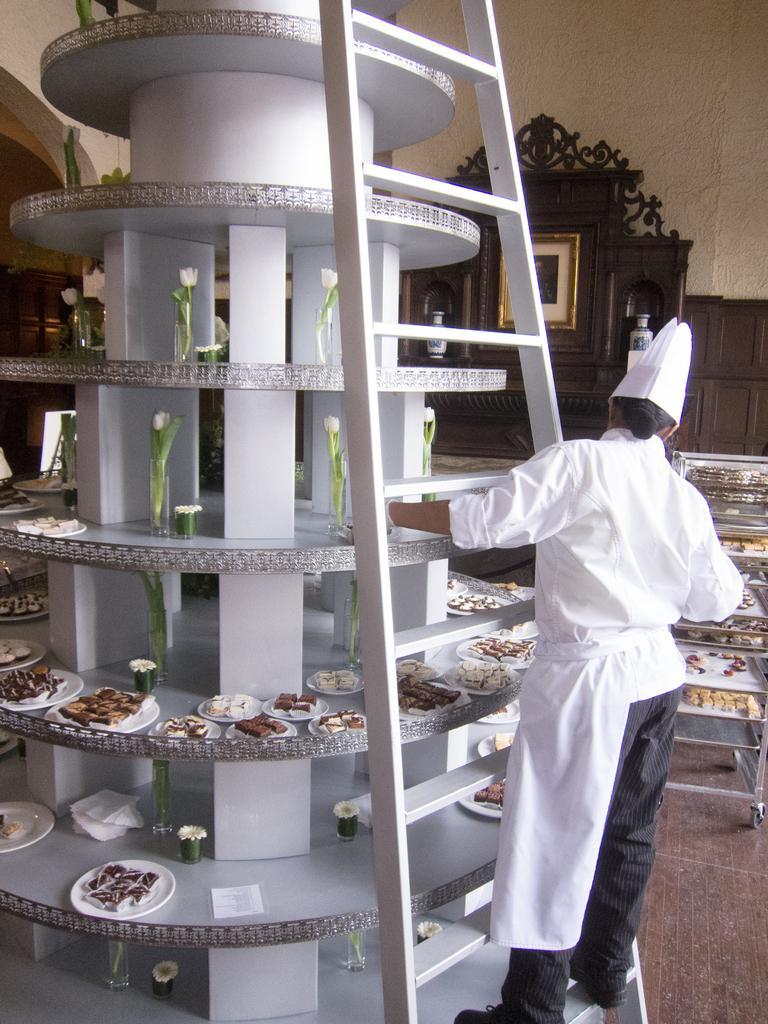Describe this image in one or two sentences. In this picture I can see food in the plates and flowers in the glass jar and I can see a ladder and a woman standing on It and she wore a cap on her head and I can see a photo frame. 